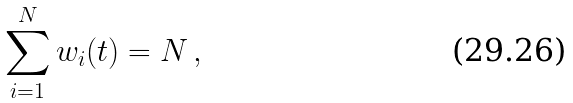Convert formula to latex. <formula><loc_0><loc_0><loc_500><loc_500>\sum _ { i = 1 } ^ { N } w _ { i } ( t ) = N \, ,</formula> 